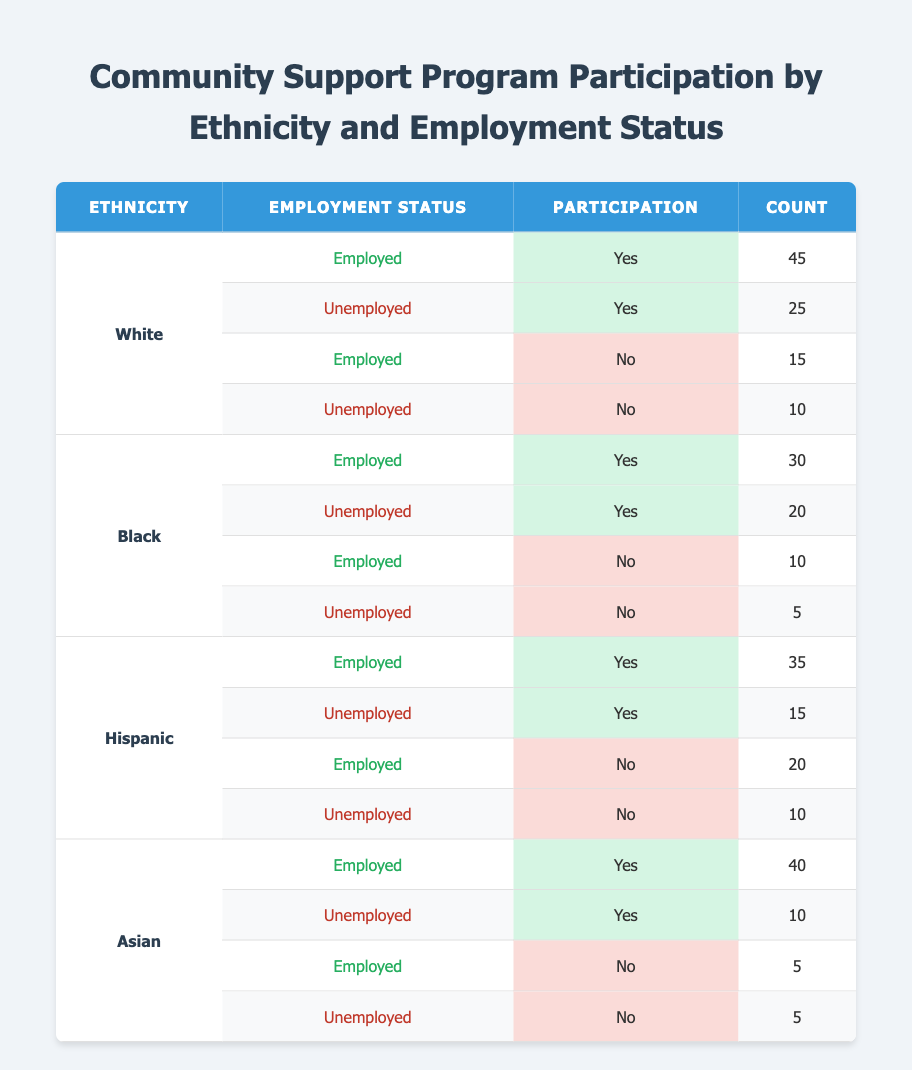What is the total number of White participants who engaged in the program? To find the total number of White participants, we can add the counts for "Yes" and "No" participation under the "White" ethnicity. So, 45 (Employed Yes) + 25 (Unemployed Yes) + 15 (Employed No) + 10 (Unemployed No) = 95.
Answer: 95 How many Black participants did not participate in the program? For Black participants who did not participate, we look at the counts under "No" participation – 10 (Employed No) and 5 (Unemployed No). Adding these gives us 10 + 5 = 15.
Answer: 15 Is the participation rate among employed White individuals higher than that of unemployed White individuals? The participation rate for employed White individuals is 45 (Yes) out of 60 total (45 Yes + 15 No), which is 75%. For unemployed White individuals, it is 25 (Yes) out of 35 total (25 Yes + 10 No), which is about 71.43%. Since 75% > 71.43%, the answer is yes.
Answer: Yes What is the average count of unemployment status across all ethnicities? To find the average count of unemployment status, we sum the counts for unemployed "Yes" and "No" across all ethnicities: (25 + 20 + 15 + 10) for Yes and (10 + 5 + 10 + 5) for No, totaling 25 + 20 + 15 + 10 + 10 + 5 + 10 + 5 = 105. There are 8 data points, so the average is 105/8 = 13.125.
Answer: 13.125 Which ethnic group has the highest number of participants who said "Yes" to participation? We will look at the "Yes" participation counts for each ethnicity: White has 45, Black has 30, Hispanic has 35, and Asian has 40. The highest number is from the White group with 45.
Answer: White Did more unemployed Hispanics participate compared to unemployed Blacks? We check the counts: Unemployed Hispanics participating (Yes) is 15 and those who did not (No) is 10, totaling 25. For unemployed Blacks, Yes is 20 and No is 5, totaling 25. Since both groups have the same total of 25, the answer is no for more.
Answer: No How many more employed Asian participants are there compared to unemployed Asian participants? For employed Asians, the count is 40 (Yes) + 5 (No) = 45. For unemployed Asians, the counts are 10 (Yes) + 5 (No) = 15. The difference is 45 - 15 = 30 more employed participants than unemployed.
Answer: 30 What is the ratio of total Hispanic participants who participated versus those who did not participate? The Hispanic participants who participated are counted as 35 (Employed Yes) + 15 (Unemployed Yes) = 50, and those who did not participate are 20 (Employed No) + 10 (Unemployed No) = 30. The ratio is 50:30, simplifying to 5:3.
Answer: 5:3 